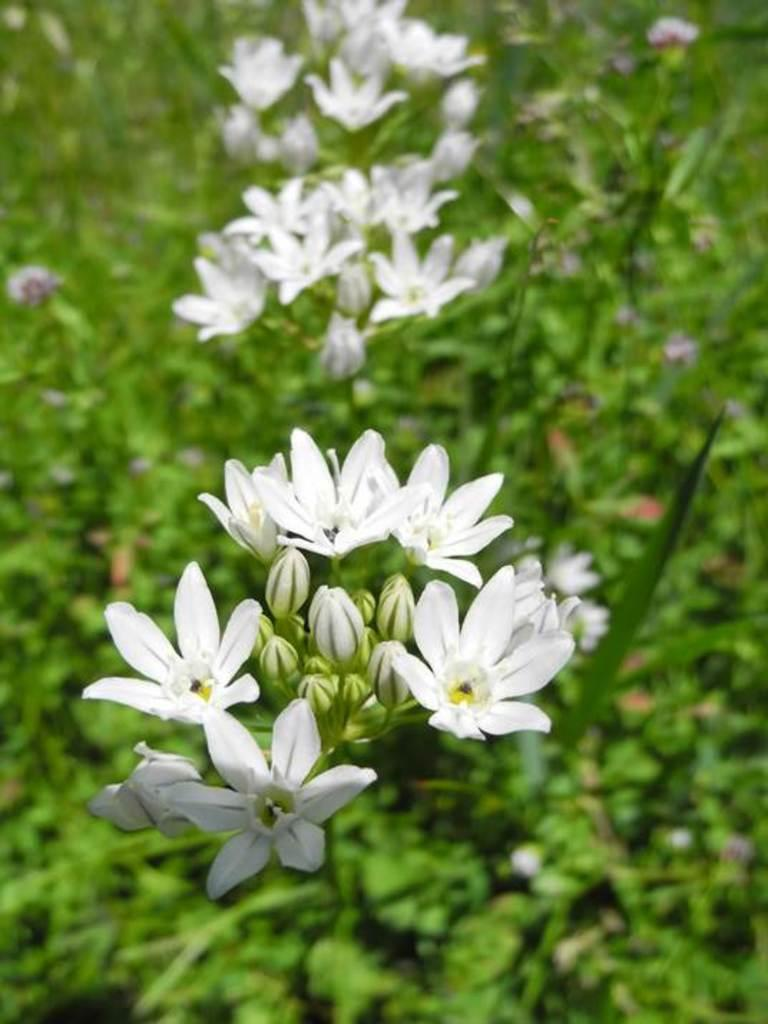What type of flora is present in the image? There are flowers in the image. What color are the flowers? The flowers are white in color. What else can be seen at the bottom of the image? There are plants at the bottom of the image. What color is associated with the leaves in the image? Green leaves are visible in the image. How many eyes can be seen on the flowers in the image? Flowers do not have eyes, so there are no eyes visible on the flowers in the image. 